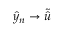Convert formula to latex. <formula><loc_0><loc_0><loc_500><loc_500>\hat { y } _ { n } \rightarrow \tilde { \hat { u } }</formula> 